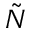<formula> <loc_0><loc_0><loc_500><loc_500>\tilde { N }</formula> 